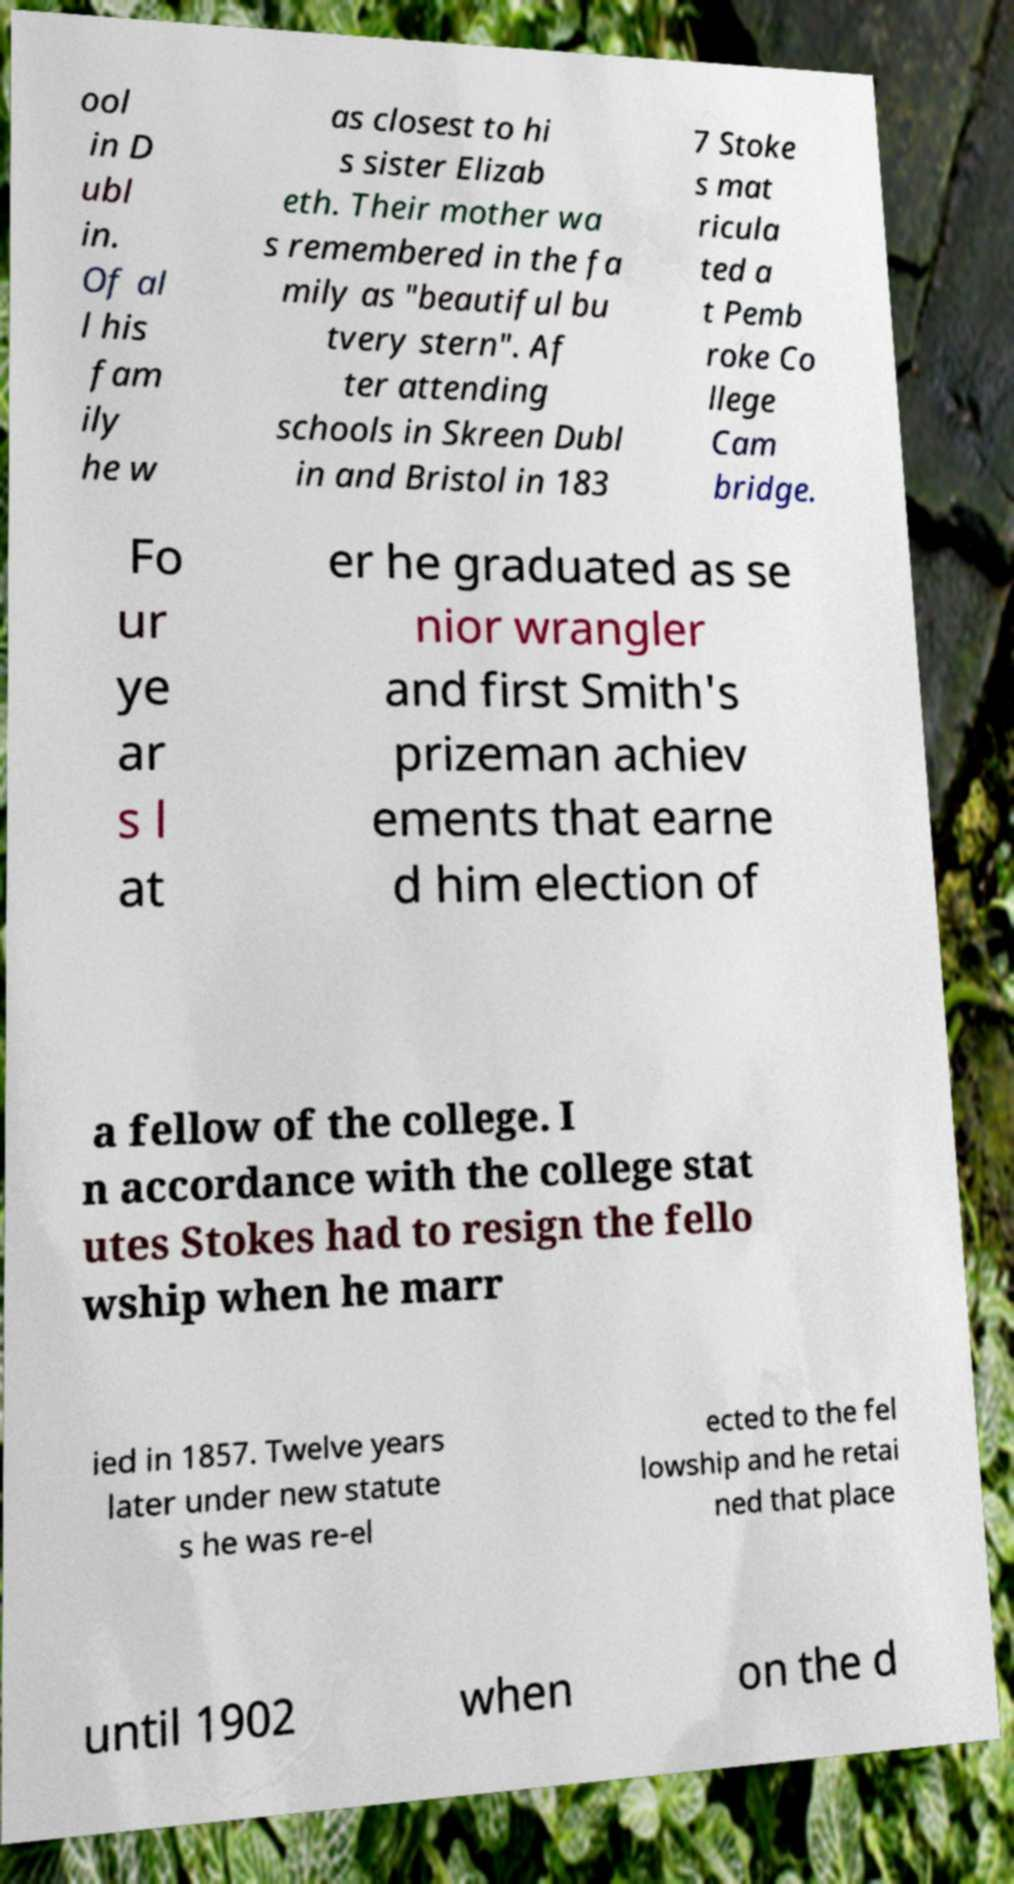What messages or text are displayed in this image? I need them in a readable, typed format. ool in D ubl in. Of al l his fam ily he w as closest to hi s sister Elizab eth. Their mother wa s remembered in the fa mily as "beautiful bu tvery stern". Af ter attending schools in Skreen Dubl in and Bristol in 183 7 Stoke s mat ricula ted a t Pemb roke Co llege Cam bridge. Fo ur ye ar s l at er he graduated as se nior wrangler and first Smith's prizeman achiev ements that earne d him election of a fellow of the college. I n accordance with the college stat utes Stokes had to resign the fello wship when he marr ied in 1857. Twelve years later under new statute s he was re-el ected to the fel lowship and he retai ned that place until 1902 when on the d 